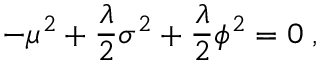Convert formula to latex. <formula><loc_0><loc_0><loc_500><loc_500>- \mu ^ { 2 } + \frac { \lambda } { 2 } \sigma ^ { 2 } + \frac { \lambda } { 2 } \phi ^ { 2 } = 0 \, ,</formula> 